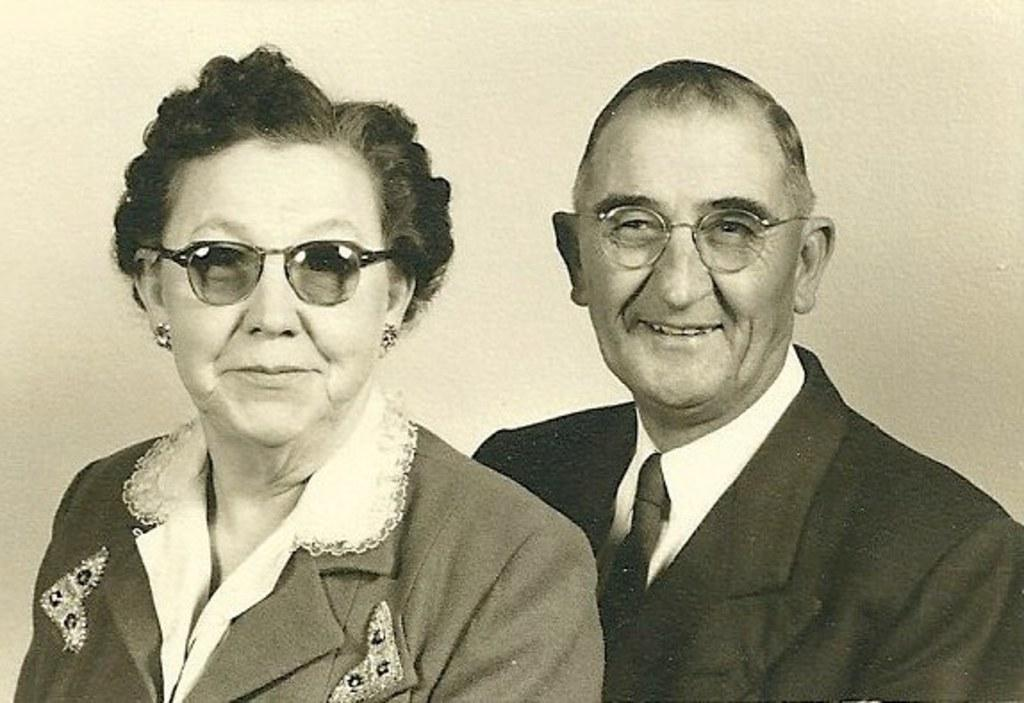What is the color scheme of the image? The image is black and white. What can be seen on the left side of the image? There is a picture of a woman on the left side of the image. What can be seen on the right side of the image? There is a picture of a man on the right side of the image. What is visible in the background of the image? There is a wall in the background of the image. How many vases are present in the image? There are no vases present in the image. What type of snakes can be seen slithering on the wall in the image? There are no snakes present in the image; the background only features a wall. 